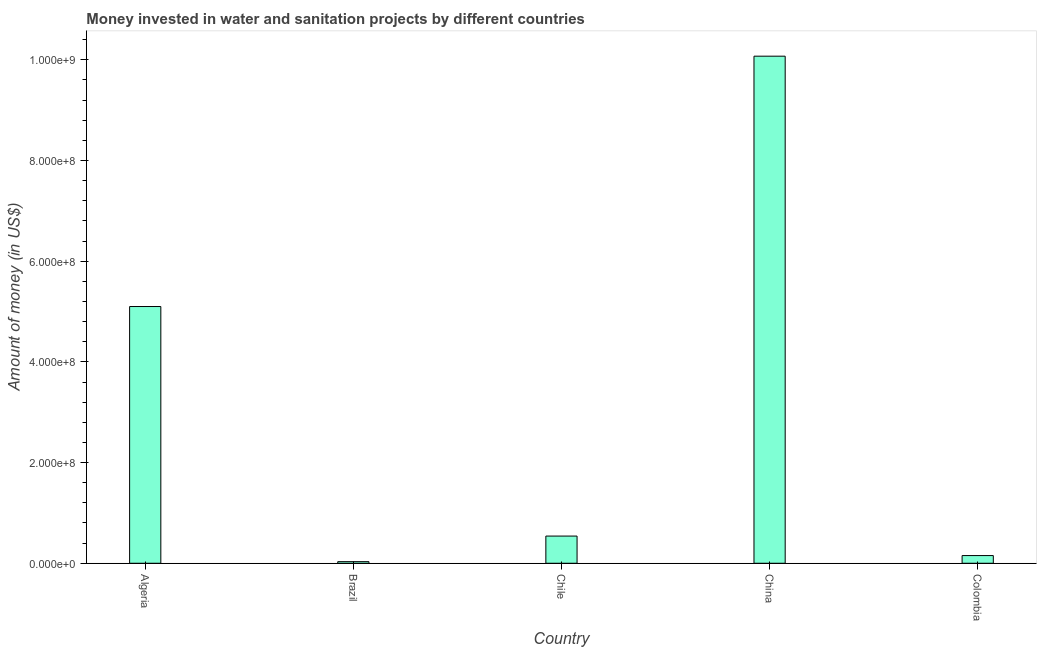Does the graph contain any zero values?
Ensure brevity in your answer.  No. What is the title of the graph?
Keep it short and to the point. Money invested in water and sanitation projects by different countries. What is the label or title of the X-axis?
Your answer should be compact. Country. What is the label or title of the Y-axis?
Your response must be concise. Amount of money (in US$). What is the investment in Algeria?
Ensure brevity in your answer.  5.10e+08. Across all countries, what is the maximum investment?
Make the answer very short. 1.01e+09. Across all countries, what is the minimum investment?
Offer a terse response. 3.16e+06. In which country was the investment maximum?
Make the answer very short. China. What is the sum of the investment?
Keep it short and to the point. 1.59e+09. What is the difference between the investment in Brazil and Chile?
Keep it short and to the point. -5.08e+07. What is the average investment per country?
Your response must be concise. 3.18e+08. What is the median investment?
Offer a terse response. 5.40e+07. In how many countries, is the investment greater than 400000000 US$?
Offer a terse response. 2. What is the ratio of the investment in Brazil to that in Chile?
Offer a terse response. 0.06. Is the investment in Algeria less than that in China?
Make the answer very short. Yes. What is the difference between the highest and the second highest investment?
Provide a succinct answer. 4.97e+08. Is the sum of the investment in Brazil and China greater than the maximum investment across all countries?
Your answer should be compact. Yes. What is the difference between the highest and the lowest investment?
Keep it short and to the point. 1.00e+09. How many bars are there?
Offer a very short reply. 5. Are all the bars in the graph horizontal?
Give a very brief answer. No. What is the difference between two consecutive major ticks on the Y-axis?
Ensure brevity in your answer.  2.00e+08. What is the Amount of money (in US$) of Algeria?
Provide a short and direct response. 5.10e+08. What is the Amount of money (in US$) in Brazil?
Your response must be concise. 3.16e+06. What is the Amount of money (in US$) of Chile?
Make the answer very short. 5.40e+07. What is the Amount of money (in US$) of China?
Offer a terse response. 1.01e+09. What is the Amount of money (in US$) in Colombia?
Ensure brevity in your answer.  1.53e+07. What is the difference between the Amount of money (in US$) in Algeria and Brazil?
Make the answer very short. 5.07e+08. What is the difference between the Amount of money (in US$) in Algeria and Chile?
Your answer should be compact. 4.56e+08. What is the difference between the Amount of money (in US$) in Algeria and China?
Provide a succinct answer. -4.97e+08. What is the difference between the Amount of money (in US$) in Algeria and Colombia?
Make the answer very short. 4.95e+08. What is the difference between the Amount of money (in US$) in Brazil and Chile?
Give a very brief answer. -5.08e+07. What is the difference between the Amount of money (in US$) in Brazil and China?
Your answer should be very brief. -1.00e+09. What is the difference between the Amount of money (in US$) in Brazil and Colombia?
Offer a terse response. -1.21e+07. What is the difference between the Amount of money (in US$) in Chile and China?
Offer a terse response. -9.53e+08. What is the difference between the Amount of money (in US$) in Chile and Colombia?
Keep it short and to the point. 3.87e+07. What is the difference between the Amount of money (in US$) in China and Colombia?
Your response must be concise. 9.92e+08. What is the ratio of the Amount of money (in US$) in Algeria to that in Brazil?
Offer a terse response. 161.19. What is the ratio of the Amount of money (in US$) in Algeria to that in Chile?
Offer a very short reply. 9.44. What is the ratio of the Amount of money (in US$) in Algeria to that in China?
Make the answer very short. 0.51. What is the ratio of the Amount of money (in US$) in Algeria to that in Colombia?
Your answer should be compact. 33.38. What is the ratio of the Amount of money (in US$) in Brazil to that in Chile?
Provide a succinct answer. 0.06. What is the ratio of the Amount of money (in US$) in Brazil to that in China?
Your answer should be very brief. 0. What is the ratio of the Amount of money (in US$) in Brazil to that in Colombia?
Offer a very short reply. 0.21. What is the ratio of the Amount of money (in US$) in Chile to that in China?
Offer a terse response. 0.05. What is the ratio of the Amount of money (in US$) in Chile to that in Colombia?
Your answer should be compact. 3.53. What is the ratio of the Amount of money (in US$) in China to that in Colombia?
Your answer should be very brief. 65.92. 